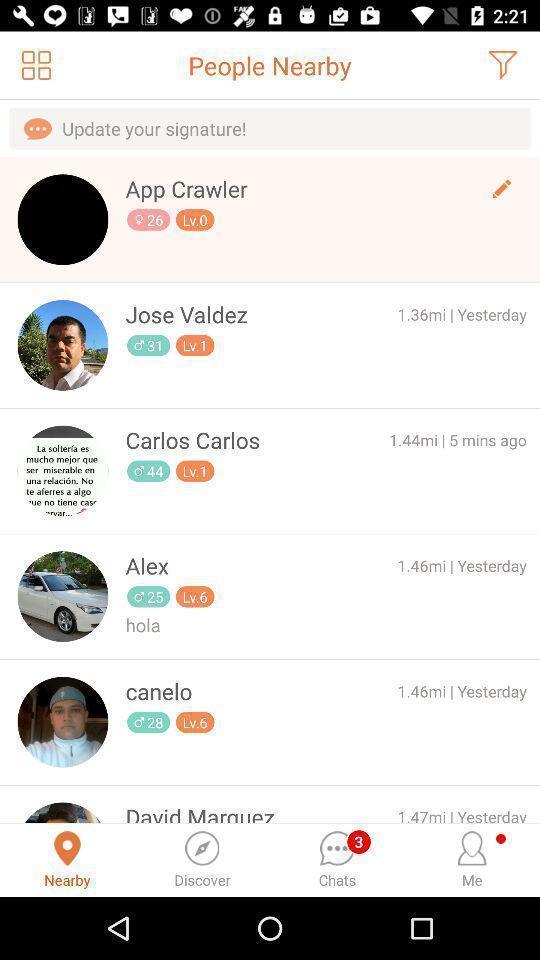Describe the key features of this screenshot. Screen showing the options for people nearby. 